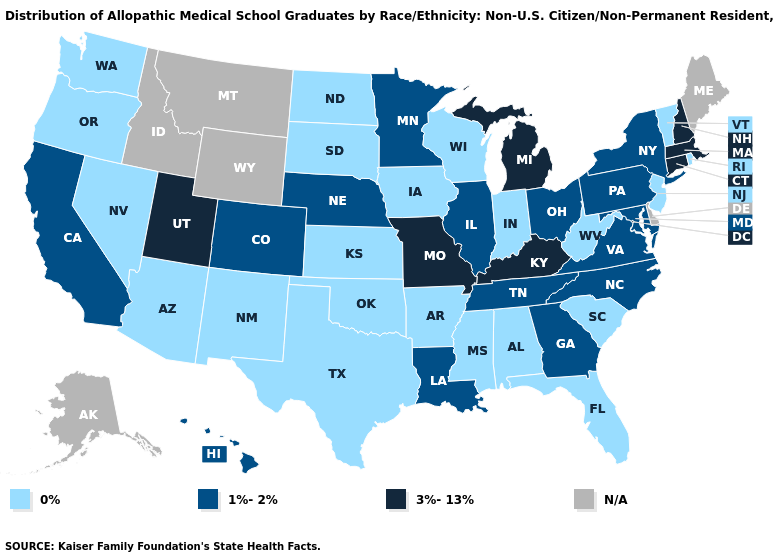What is the highest value in the USA?
Quick response, please. 3%-13%. Among the states that border Montana , which have the highest value?
Be succinct. North Dakota, South Dakota. Which states have the lowest value in the USA?
Quick response, please. Alabama, Arizona, Arkansas, Florida, Indiana, Iowa, Kansas, Mississippi, Nevada, New Jersey, New Mexico, North Dakota, Oklahoma, Oregon, Rhode Island, South Carolina, South Dakota, Texas, Vermont, Washington, West Virginia, Wisconsin. What is the value of Wisconsin?
Answer briefly. 0%. What is the value of Louisiana?
Keep it brief. 1%-2%. Among the states that border Mississippi , which have the lowest value?
Keep it brief. Alabama, Arkansas. What is the lowest value in the West?
Write a very short answer. 0%. Does Nevada have the lowest value in the West?
Quick response, please. Yes. How many symbols are there in the legend?
Answer briefly. 4. Which states have the lowest value in the Northeast?
Short answer required. New Jersey, Rhode Island, Vermont. What is the value of Missouri?
Quick response, please. 3%-13%. What is the value of Michigan?
Be succinct. 3%-13%. Name the states that have a value in the range N/A?
Short answer required. Alaska, Delaware, Idaho, Maine, Montana, Wyoming. 